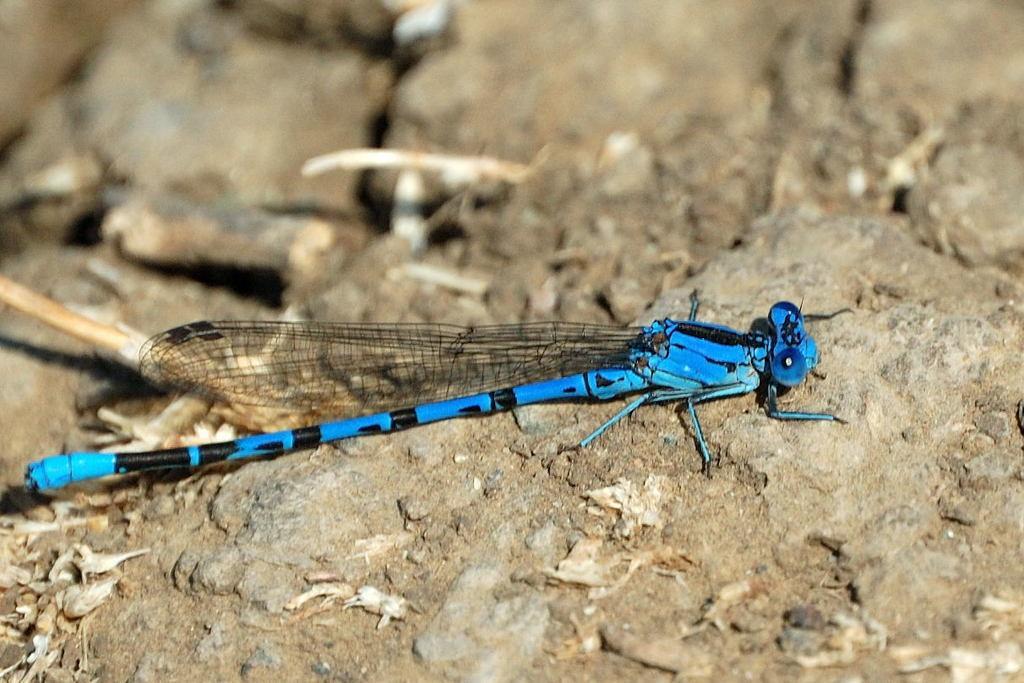Can you describe this image briefly? In this image we can see a fly on the rock land which is in blue and black color. 